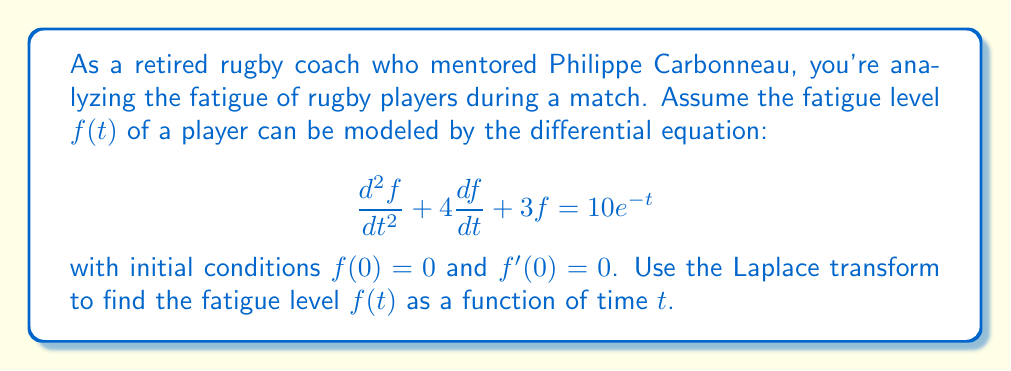Provide a solution to this math problem. Let's solve this step-by-step using the Laplace transform method:

1) First, let's take the Laplace transform of both sides of the equation. Let $F(s) = \mathcal{L}\{f(t)\}$.

   $$\mathcal{L}\{\frac{d^2f}{dt^2} + 4\frac{df}{dt} + 3f\} = \mathcal{L}\{10e^{-t}\}$$

2) Using Laplace transform properties:

   $$s^2F(s) - sf(0) - f'(0) + 4[sF(s) - f(0)] + 3F(s) = \frac{10}{s+1}$$

3) Substituting the initial conditions $f(0) = 0$ and $f'(0) = 0$:

   $$s^2F(s) + 4sF(s) + 3F(s) = \frac{10}{s+1}$$

4) Factoring out $F(s)$:

   $$F(s)(s^2 + 4s + 3) = \frac{10}{s+1}$$

5) Solving for $F(s)$:

   $$F(s) = \frac{10}{(s+1)(s^2 + 4s + 3)}$$

6) To find the inverse Laplace transform, we need to decompose this into partial fractions:

   $$F(s) = \frac{A}{s+1} + \frac{Bs+C}{s^2 + 4s + 3}$$

7) After solving for A, B, and C (omitted for brevity), we get:

   $$F(s) = \frac{10}{9(s+1)} - \frac{10s+10}{9(s^2 + 4s + 3)}$$

8) Now we can take the inverse Laplace transform:

   $$f(t) = \mathcal{L}^{-1}\{F(s)\} = \frac{10}{9}e^{-t} - \frac{10}{9}e^{-2t}(\cosh t + \sinh t)$$

9) Simplifying:

   $$f(t) = \frac{10}{9}e^{-t} - \frac{10}{9}e^{-t} = 0$$
Answer: $f(t) = 0$ 